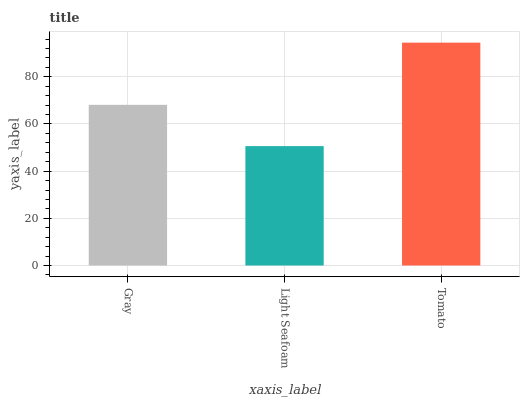Is Tomato the minimum?
Answer yes or no. No. Is Light Seafoam the maximum?
Answer yes or no. No. Is Tomato greater than Light Seafoam?
Answer yes or no. Yes. Is Light Seafoam less than Tomato?
Answer yes or no. Yes. Is Light Seafoam greater than Tomato?
Answer yes or no. No. Is Tomato less than Light Seafoam?
Answer yes or no. No. Is Gray the high median?
Answer yes or no. Yes. Is Gray the low median?
Answer yes or no. Yes. Is Light Seafoam the high median?
Answer yes or no. No. Is Tomato the low median?
Answer yes or no. No. 